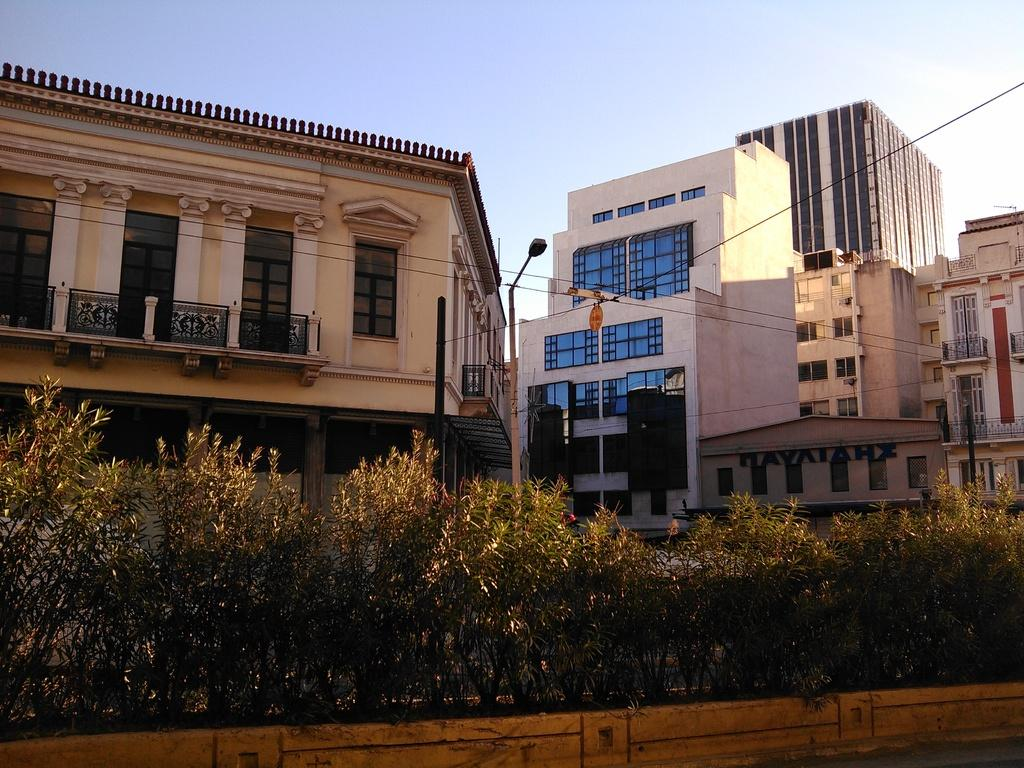What type of vegetation is present on the ground in the image? There are plants on the ground in the image. What can be seen in the distance behind the plants? There are buildings visible in the background of the image. What type of structure is present near the plants? There is a street light pole in the image. What is the condition of the sky in the image? The sky is clear in the image. What is the name of the power station in the image? There is no power station present in the image. What level of the building can be seen in the image? The image does not provide information about the level of the building; it only shows the exterior of the buildings. 